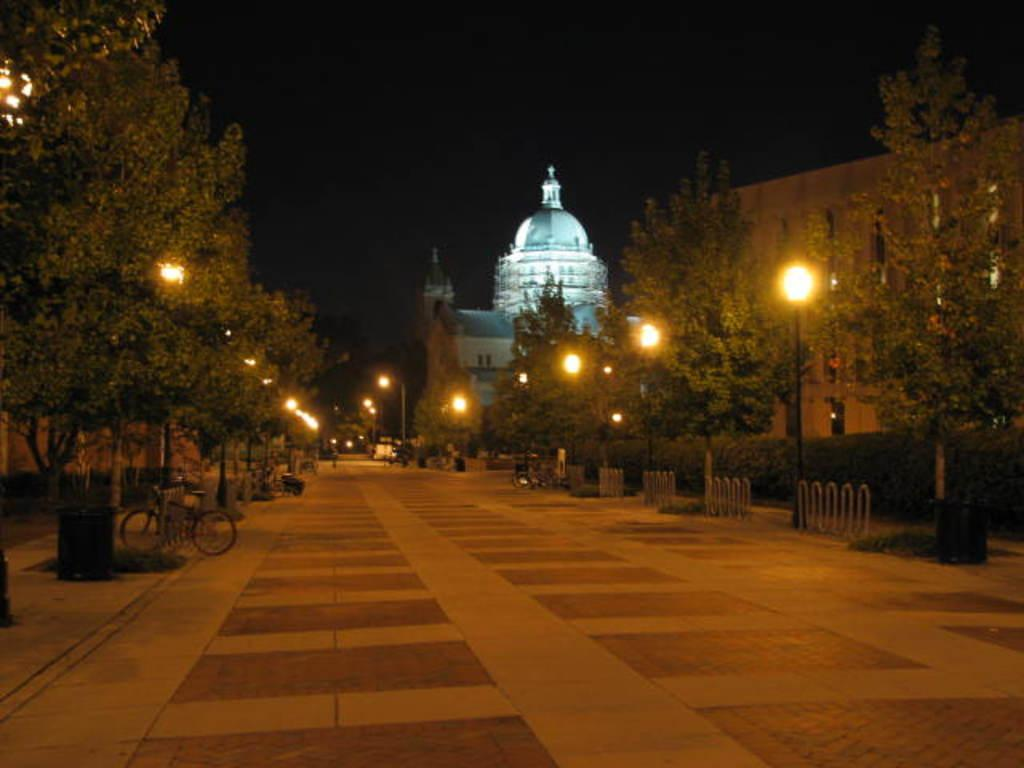What type of path is visible in the image? There is a walkway in the image. What structure can be seen alongside the walkway? There is a fence in the image. What type of vegetation is present in the image? There are plants and trees in the image. What can be seen in the distance in the image? There are buildings in the background of the image. What type of bean is growing on the fence in the image? There are no beans present in the image; it features a walkway, fence, plants, trees, and buildings. How many women are visible in the image? There are no women present in the image. 